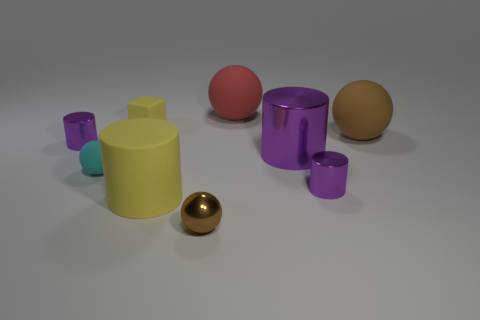How many brown balls must be subtracted to get 1 brown balls? 1 Subtract all matte spheres. How many spheres are left? 1 Subtract all cylinders. How many objects are left? 5 Subtract 2 cylinders. How many cylinders are left? 2 Subtract all purple cylinders. Subtract all green blocks. How many cylinders are left? 1 Subtract all red balls. How many yellow cylinders are left? 1 Subtract all small brown rubber cubes. Subtract all rubber objects. How many objects are left? 4 Add 7 red things. How many red things are left? 8 Add 6 gray matte cubes. How many gray matte cubes exist? 6 Add 1 tiny purple cylinders. How many objects exist? 10 